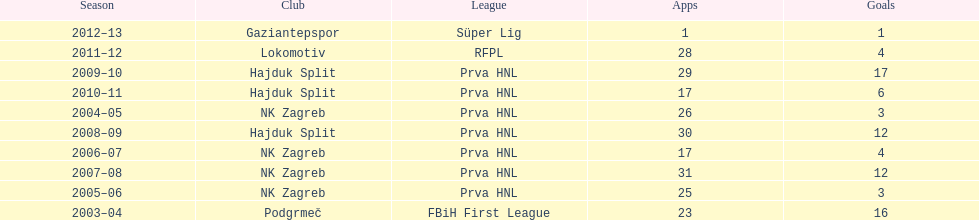Help me parse the entirety of this table. {'header': ['Season', 'Club', 'League', 'Apps', 'Goals'], 'rows': [['2012–13', 'Gaziantepspor', 'Süper Lig', '1', '1'], ['2011–12', 'Lokomotiv', 'RFPL', '28', '4'], ['2009–10', 'Hajduk Split', 'Prva HNL', '29', '17'], ['2010–11', 'Hajduk Split', 'Prva HNL', '17', '6'], ['2004–05', 'NK Zagreb', 'Prva HNL', '26', '3'], ['2008–09', 'Hajduk Split', 'Prva HNL', '30', '12'], ['2006–07', 'NK Zagreb', 'Prva HNL', '17', '4'], ['2007–08', 'NK Zagreb', 'Prva HNL', '31', '12'], ['2005–06', 'NK Zagreb', 'Prva HNL', '25', '3'], ['2003–04', 'Podgrmeč', 'FBiH First League', '23', '16']]} After scoring against bulgaria in zenica, ibricic also scored against this team in a 7-0 victory in zenica less then a month after the friendly match against bulgaria. Estonia. 